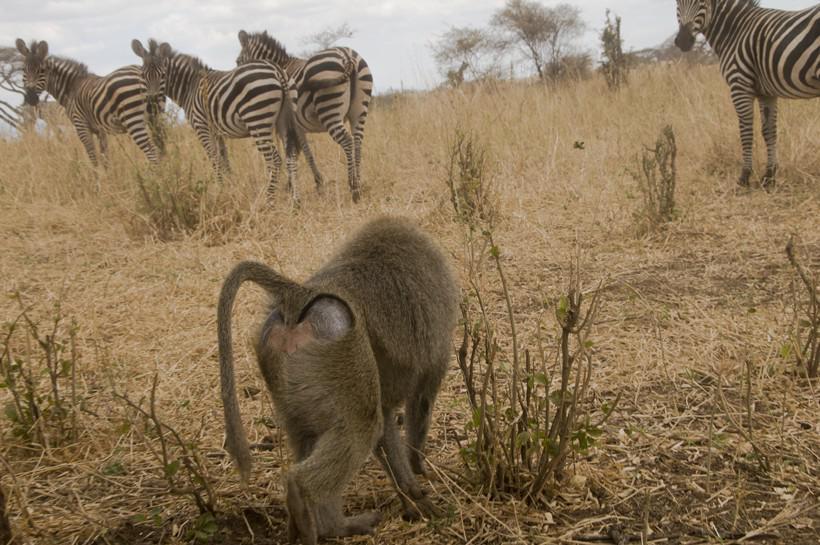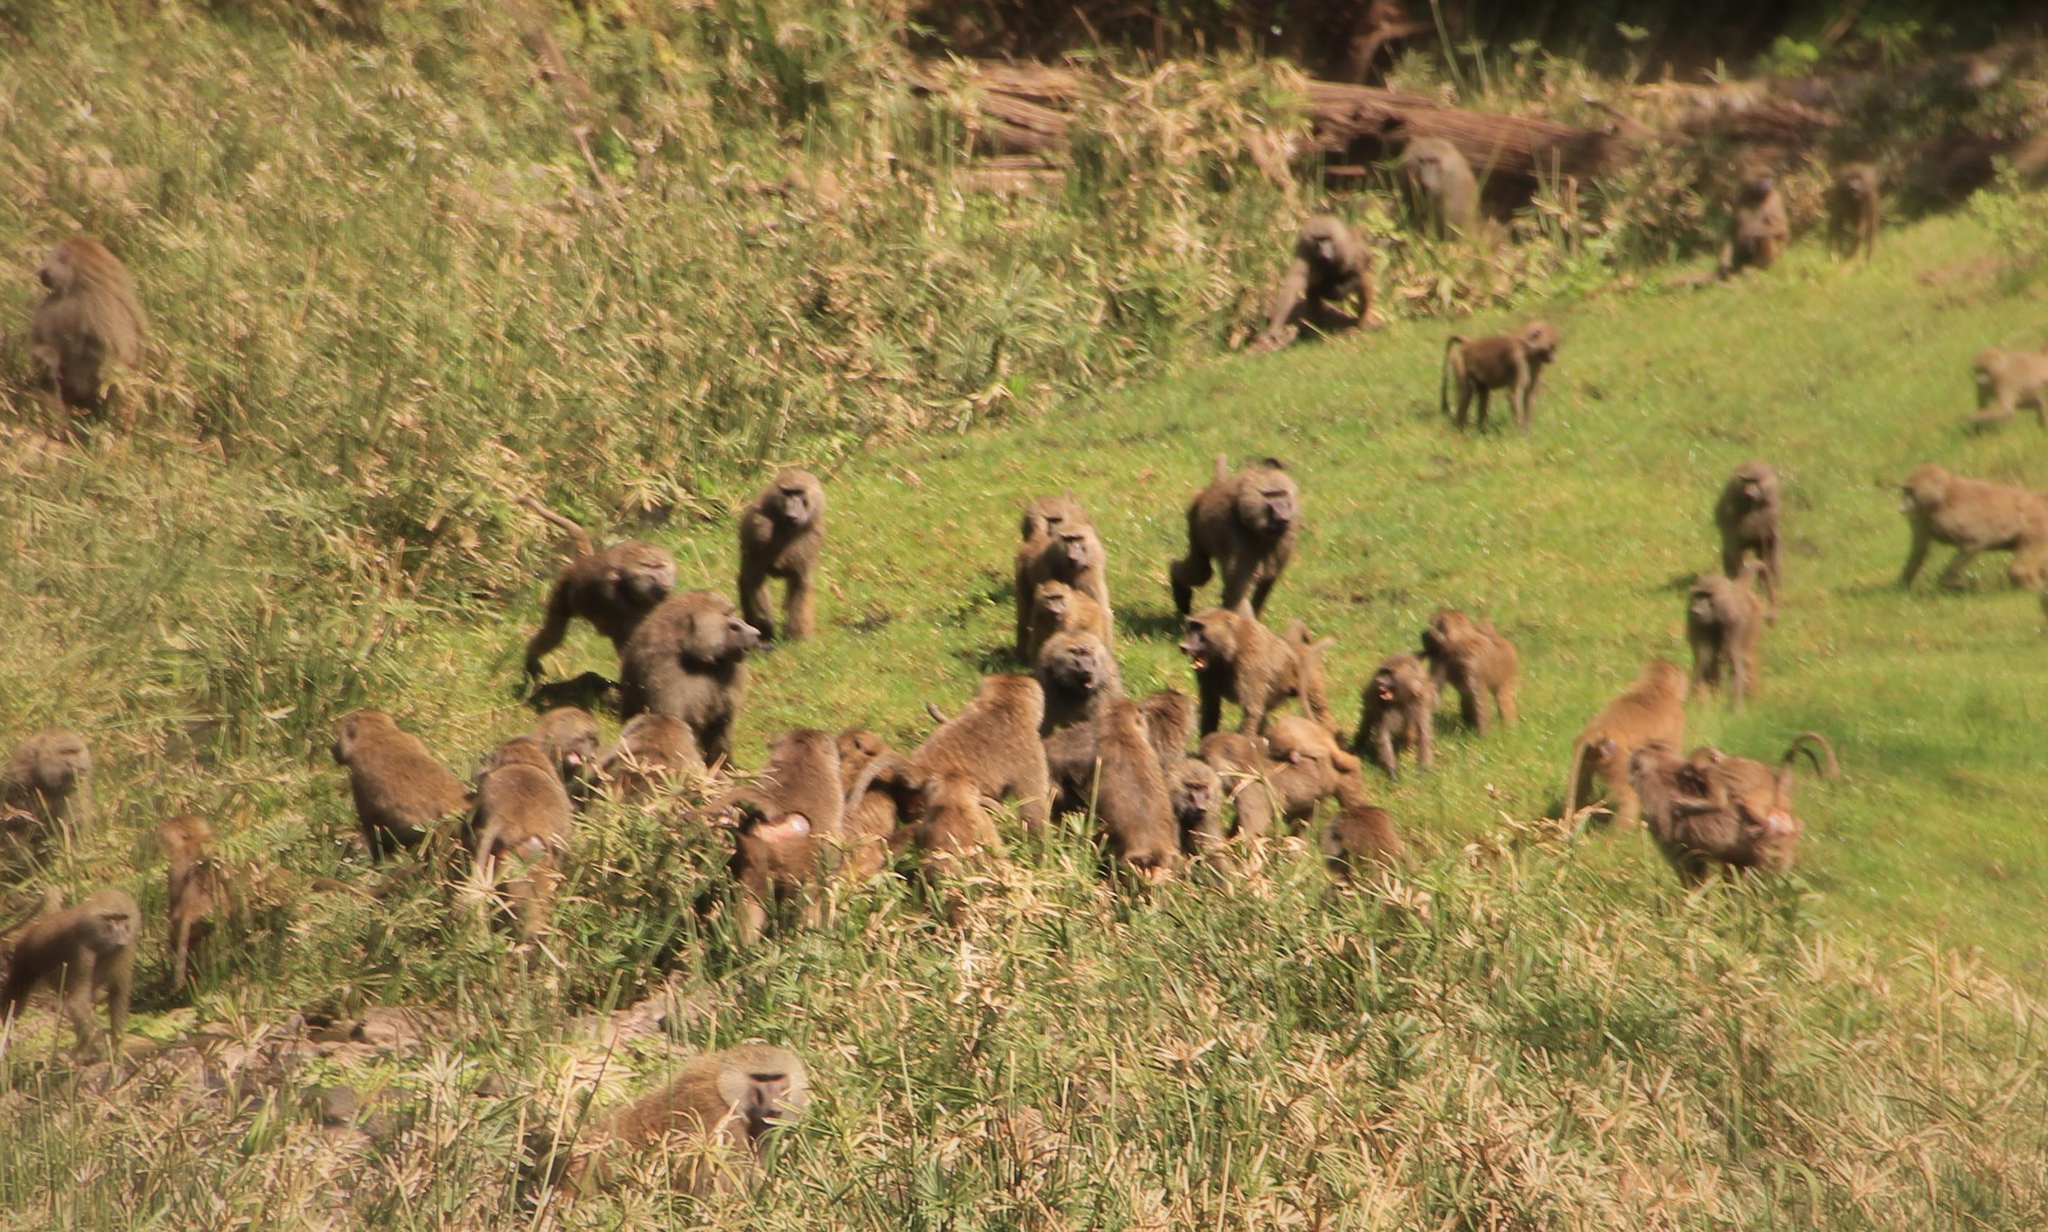The first image is the image on the left, the second image is the image on the right. Examine the images to the left and right. Is the description "There are less than ten monkeys in the image on the right." accurate? Answer yes or no. No. The first image is the image on the left, the second image is the image on the right. Examine the images to the left and right. Is the description "In one image there are multiple monkeys sitting in grass." accurate? Answer yes or no. Yes. 